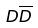Convert formula to latex. <formula><loc_0><loc_0><loc_500><loc_500>D \overline { D }</formula> 